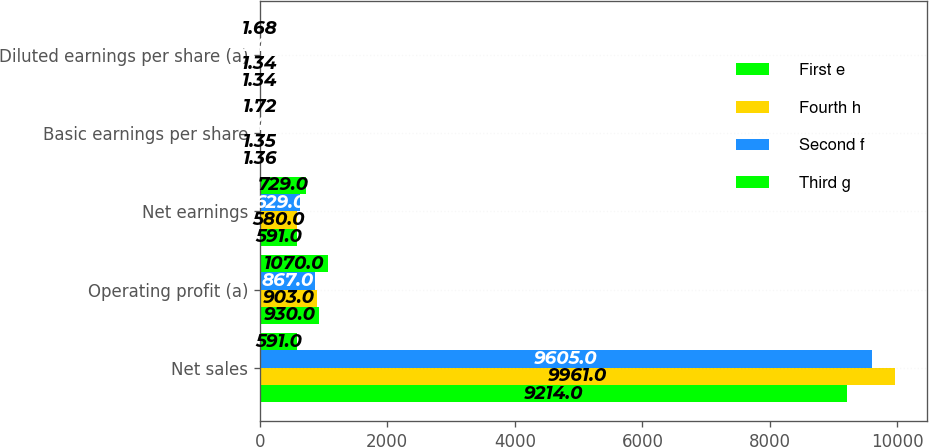Convert chart to OTSL. <chart><loc_0><loc_0><loc_500><loc_500><stacked_bar_chart><ecel><fcel>Net sales<fcel>Operating profit (a)<fcel>Net earnings<fcel>Basic earnings per share<fcel>Diluted earnings per share (a)<nl><fcel>First e<fcel>9214<fcel>930<fcel>591<fcel>1.36<fcel>1.34<nl><fcel>Fourth h<fcel>9961<fcel>903<fcel>580<fcel>1.35<fcel>1.34<nl><fcel>Second f<fcel>9605<fcel>867<fcel>629<fcel>1.48<fcel>1.46<nl><fcel>Third g<fcel>591<fcel>1070<fcel>729<fcel>1.72<fcel>1.68<nl></chart> 